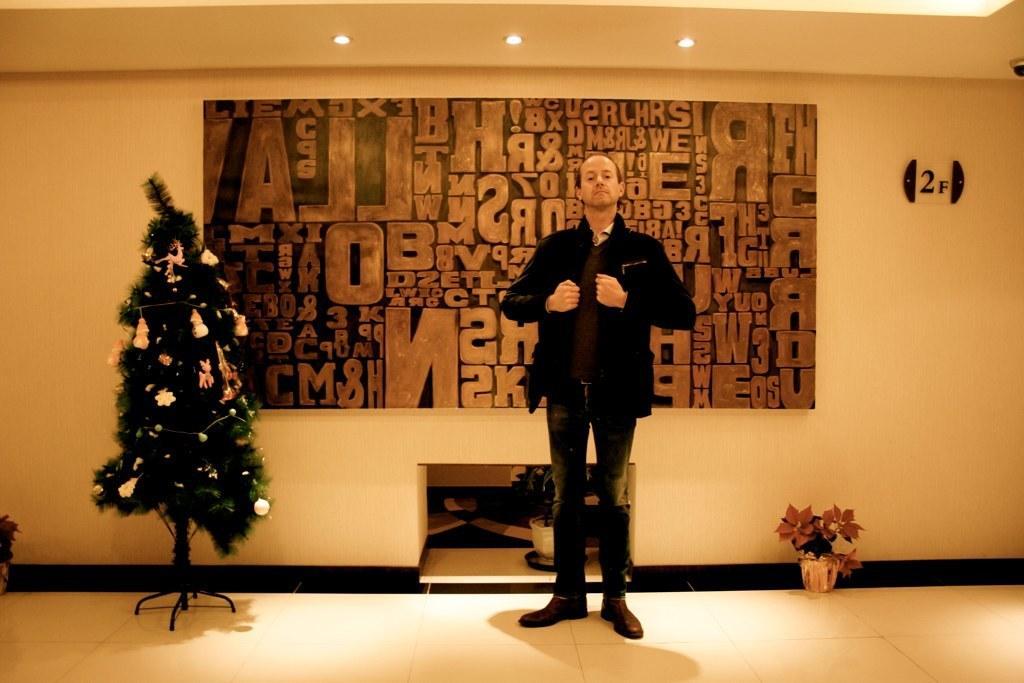Could you give a brief overview of what you see in this image? In the image we can see there is a person standing and he is wearing a jacket. Behind on the wall there is a poster of alphabets and beside there is a decorated christmas tree. 